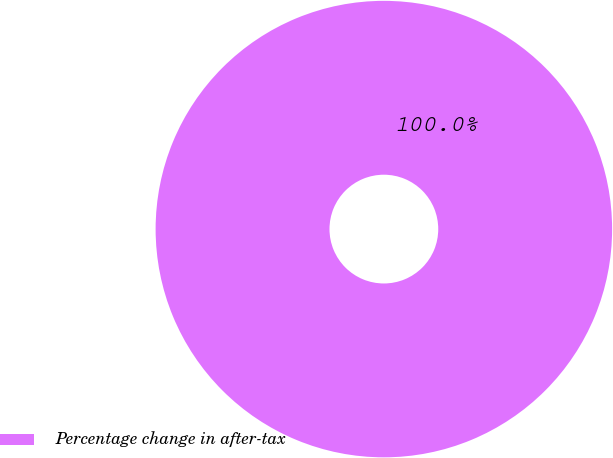<chart> <loc_0><loc_0><loc_500><loc_500><pie_chart><fcel>Percentage change in after-tax<nl><fcel>100.0%<nl></chart> 